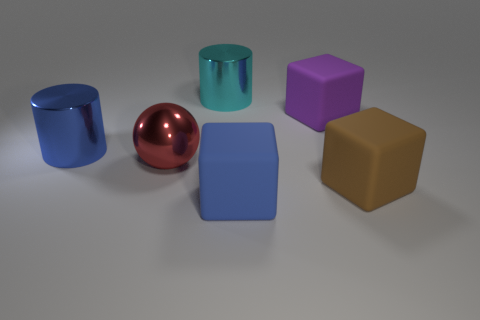How many metallic things are either purple blocks or small blue cylinders?
Your answer should be very brief. 0. Is there a big red sphere made of the same material as the blue cylinder?
Ensure brevity in your answer.  Yes. How many large objects are both behind the brown cube and left of the big purple rubber object?
Keep it short and to the point. 3. Is the number of shiny cylinders left of the blue metallic cylinder less than the number of big things on the left side of the big purple block?
Ensure brevity in your answer.  Yes. Does the big purple object have the same shape as the brown thing?
Ensure brevity in your answer.  Yes. What number of other objects are the same size as the metal sphere?
Offer a terse response. 5. How many objects are large objects that are on the right side of the blue shiny object or blue objects to the left of the big metal sphere?
Ensure brevity in your answer.  6. What number of large blue things are the same shape as the big brown rubber thing?
Your answer should be compact. 1. What is the material of the large object that is behind the big ball and on the right side of the cyan shiny object?
Provide a succinct answer. Rubber. What number of rubber objects are in front of the brown thing?
Provide a short and direct response. 1. 